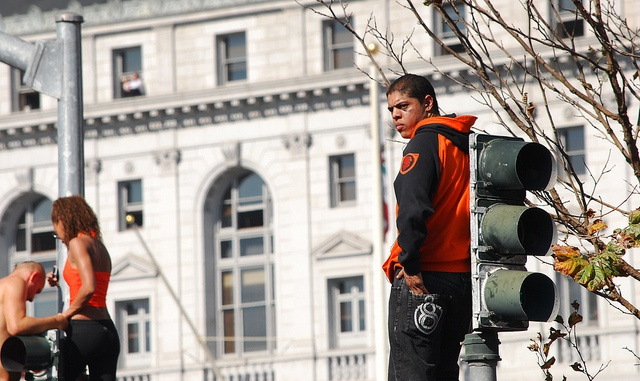Describe the objects in this image and their specific colors. I can see people in gray, black, maroon, and red tones, traffic light in gray, black, and lightgray tones, people in gray, black, maroon, salmon, and lightgray tones, and people in gray, tan, maroon, and brown tones in this image. 